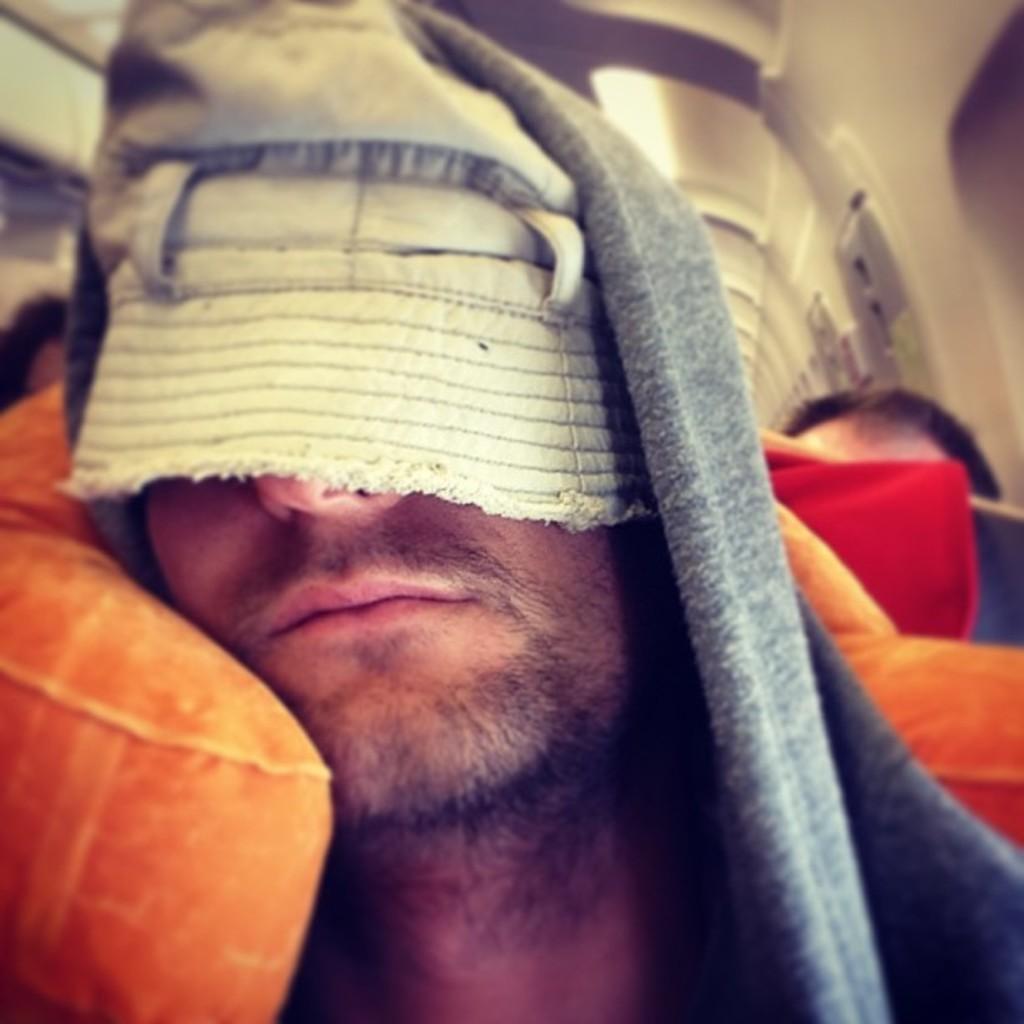Please provide a concise description of this image. The man in the front of the picture wearing a grey jacket is sleeping. Behind him, we see an orange pillow and blanket and we even see people are sitting on the seats. This picture might be clicked in a bus or a train. 